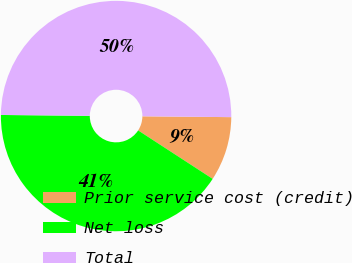Convert chart to OTSL. <chart><loc_0><loc_0><loc_500><loc_500><pie_chart><fcel>Prior service cost (credit)<fcel>Net loss<fcel>Total<nl><fcel>9.03%<fcel>40.97%<fcel>50.0%<nl></chart> 